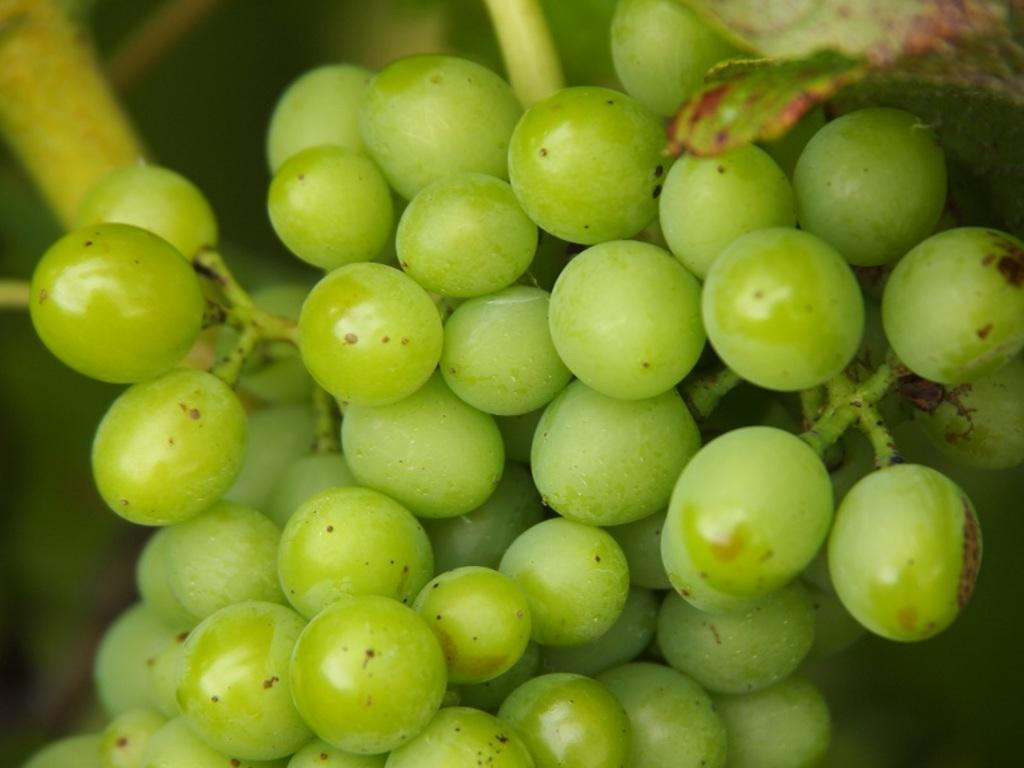What type of fruit is visible in the image? There is a bunch of grapes in the image. What parts of the grapes are also visible in the image? There are stems and leaves visible in the image. What type of ship can be seen sailing in the background of the image? There is no ship present in the image; it only features a bunch of grapes, stems, and leaves. 